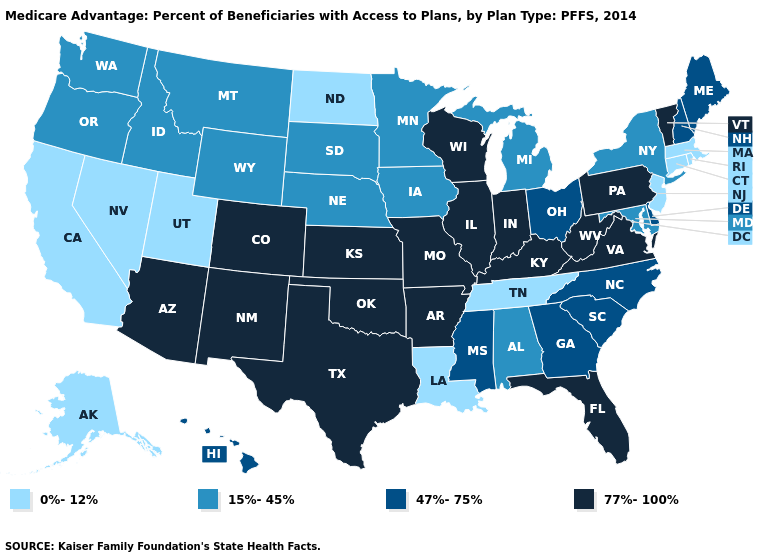What is the highest value in the Northeast ?
Concise answer only. 77%-100%. Is the legend a continuous bar?
Be succinct. No. Among the states that border Illinois , which have the highest value?
Write a very short answer. Indiana, Kentucky, Missouri, Wisconsin. Which states hav the highest value in the Northeast?
Concise answer only. Pennsylvania, Vermont. What is the value of Rhode Island?
Quick response, please. 0%-12%. Among the states that border Delaware , which have the lowest value?
Short answer required. New Jersey. Which states hav the highest value in the Northeast?
Keep it brief. Pennsylvania, Vermont. Which states have the lowest value in the USA?
Short answer required. California, Connecticut, Louisiana, Massachusetts, North Dakota, New Jersey, Nevada, Rhode Island, Alaska, Tennessee, Utah. What is the value of California?
Answer briefly. 0%-12%. Name the states that have a value in the range 15%-45%?
Give a very brief answer. Iowa, Idaho, Maryland, Michigan, Minnesota, Montana, Nebraska, New York, Oregon, South Dakota, Washington, Wyoming, Alabama. What is the value of North Carolina?
Short answer required. 47%-75%. Does Indiana have the same value as Rhode Island?
Give a very brief answer. No. What is the value of Delaware?
Quick response, please. 47%-75%. Name the states that have a value in the range 15%-45%?
Quick response, please. Iowa, Idaho, Maryland, Michigan, Minnesota, Montana, Nebraska, New York, Oregon, South Dakota, Washington, Wyoming, Alabama. 